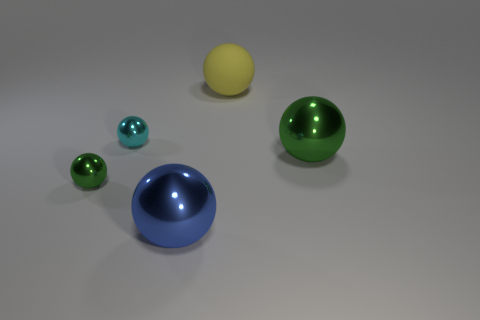Are there any cyan spheres that have the same size as the blue object? no 